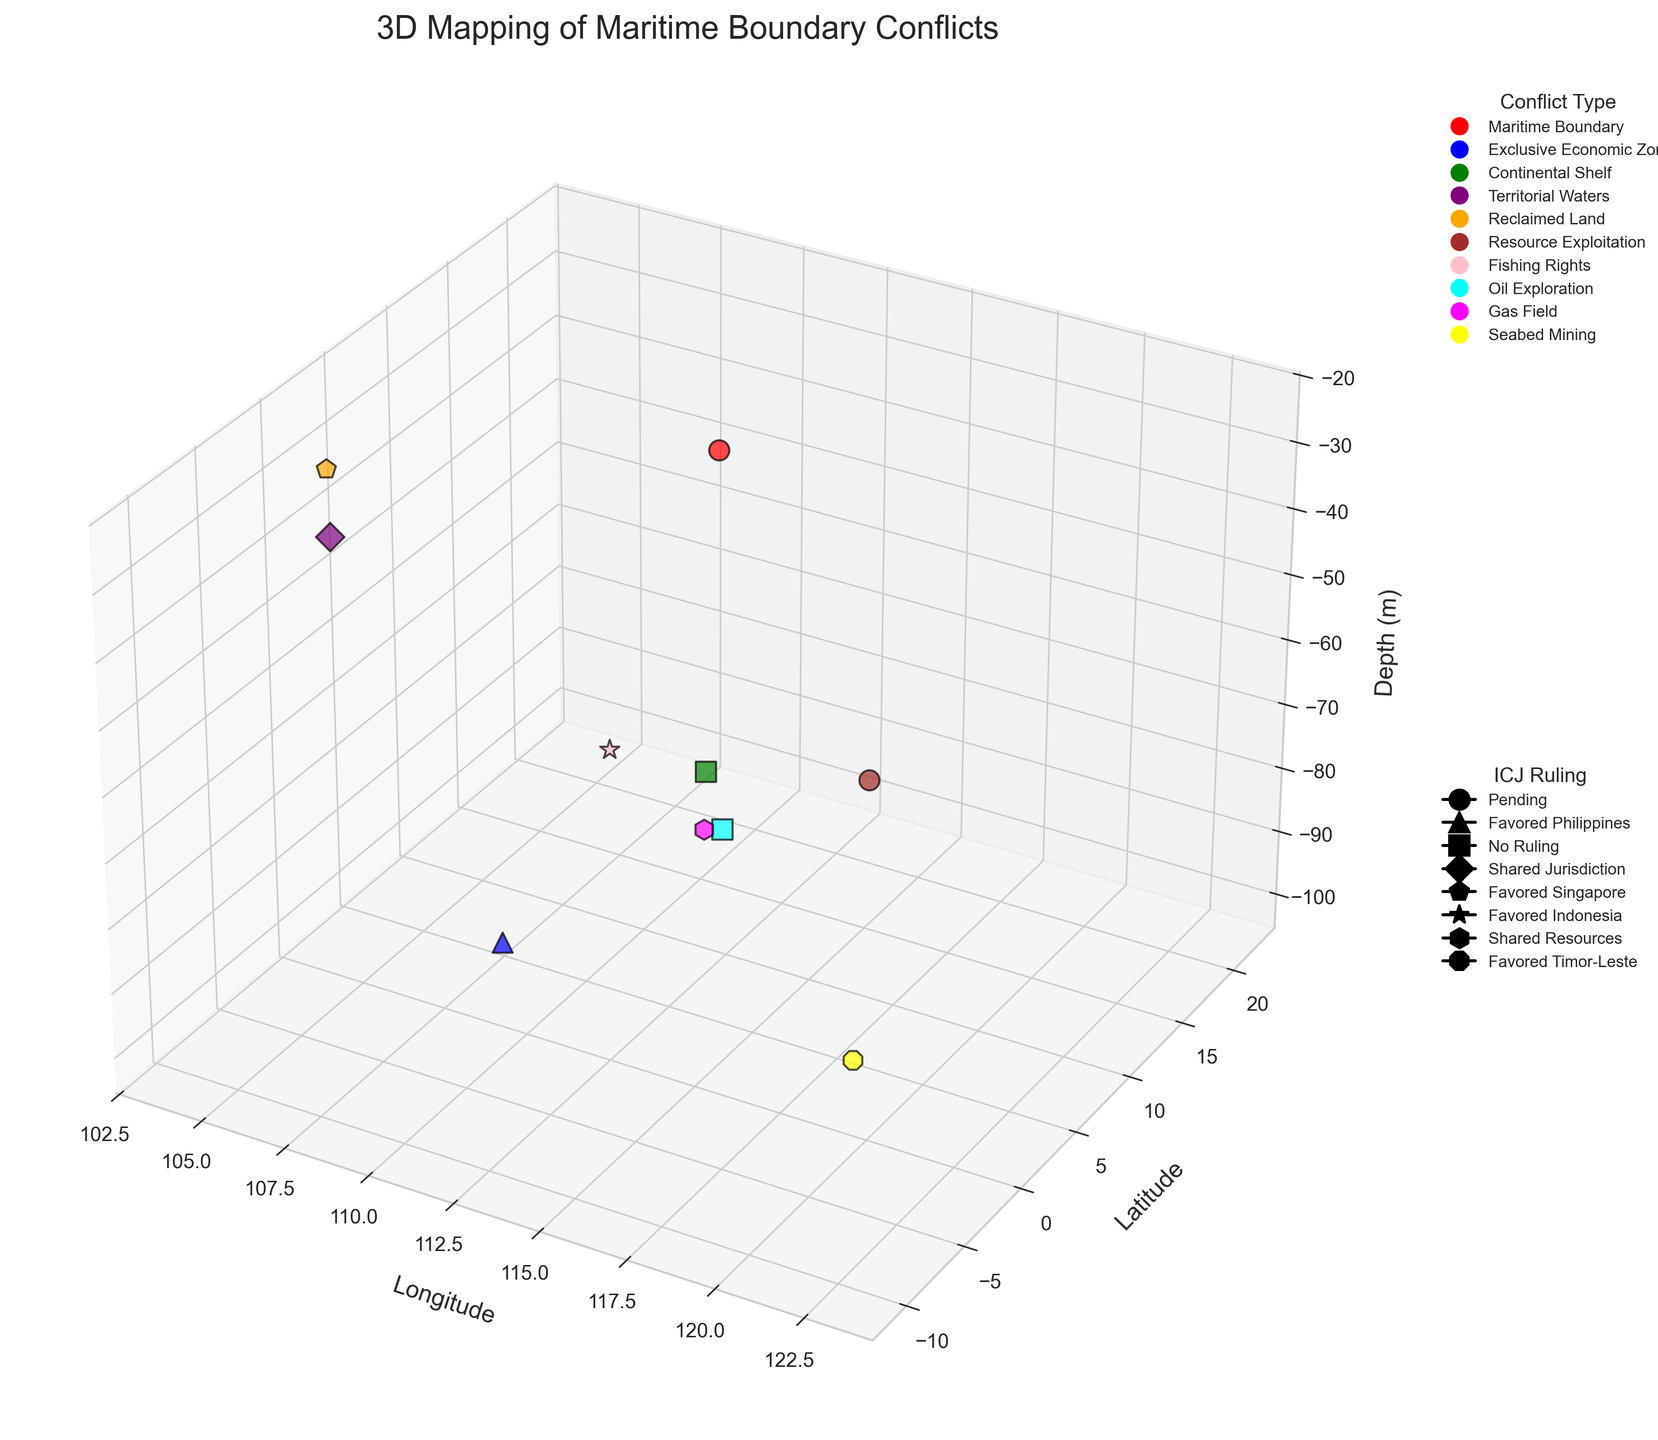How many different conflict types are represented in the figure? The legend categorizes the conflict types, each with distinct colors. Counting the unique categories gives us the total number.
Answer: 10 Which claimant appears most frequently in the dataset? Looking at the labels next to each data point, count the occurrences of each claimant to determine which one appears the most.
Answer: Malaysia What is the depth range shown on the Z-axis? Examine the Z-axis to see the minimum and maximum depth values presented in the plot.
Answer: -100 to -25 Which conflict type involves the greatest number of overlapping claims based on the figure? By observing the distribution of data points for each conflict type, one can count the number of overlapping claims. The 'Maritime Boundary' type has the most overlapping claims as evidenced by multiple data points in red.
Answer: Maritime Boundary What type of conflict is located at approximately 3.5°N and 108°E? Identify the coordinates 3.5°N (Latitude) and 108°E (Longitude) on the plot and note the color of the data point found there. Referring to the legend, determine the corresponding conflict type.
Answer: Exclusive Economic Zone For which international ruling is the number of conflict types affected highest? Examine the legend for ICJ rulings to count the different conflict types represented by each ruling.
Answer: Pending Which conflict type has the deepest point, and what is its depth? Locate the data point with the greatest negative Z-value and note its color to identify the conflict type, then check the depth. The data at -100 meters corresponds to 'Exclusive Economic Zone'.
Answer: Exclusive Economic Zone, -100 Are there any conflicts with 'No Ruling' between Malaysia and another claimant? Look for instances in the plot where the data points show 'Malaysia' and another claimant with markers indicating 'No Ruling' in the legend. The green square at 8.8 Lat and 112.3 Long confirms the 'Continental Shelf' conflict type involving Malaysia and Vietnam that falls under 'No Ruling'.
Answer: Yes How many conflicts have been resolved in favor of one party ('Favored …')? By examining the legend for markers symbolizing 'Favored ...', count the corresponding data points in the figure.
Answer: 4 